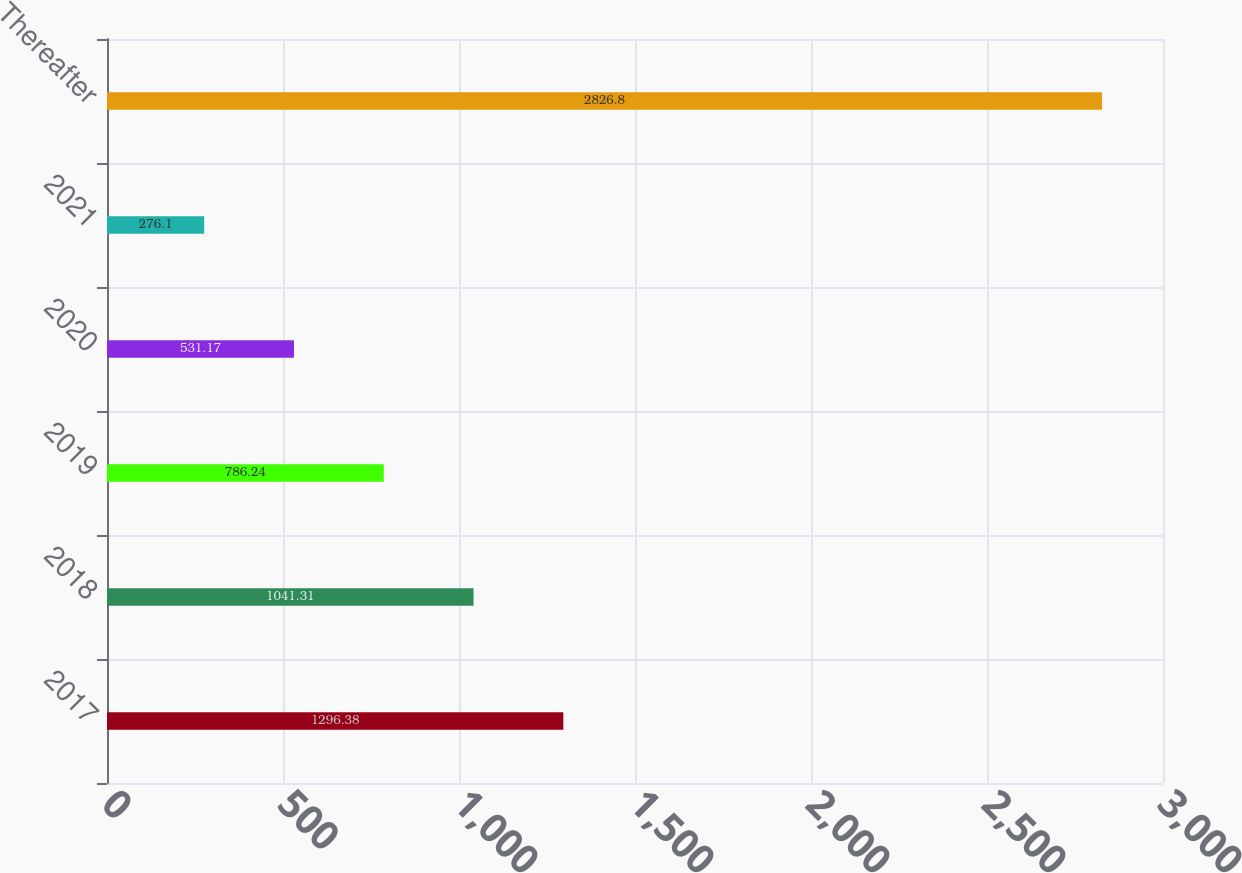Convert chart. <chart><loc_0><loc_0><loc_500><loc_500><bar_chart><fcel>2017<fcel>2018<fcel>2019<fcel>2020<fcel>2021<fcel>Thereafter<nl><fcel>1296.38<fcel>1041.31<fcel>786.24<fcel>531.17<fcel>276.1<fcel>2826.8<nl></chart> 